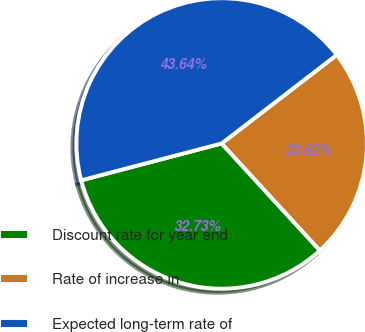<chart> <loc_0><loc_0><loc_500><loc_500><pie_chart><fcel>Discount rate for year end<fcel>Rate of increase in<fcel>Expected long-term rate of<nl><fcel>32.73%<fcel>23.62%<fcel>43.64%<nl></chart> 